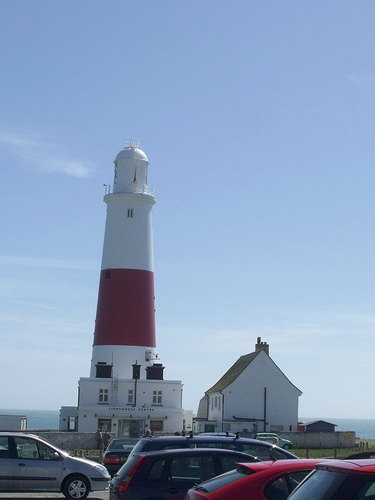<image>
Is there a car to the right of the lighthouse? No. The car is not to the right of the lighthouse. The horizontal positioning shows a different relationship. 